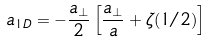<formula> <loc_0><loc_0><loc_500><loc_500>a _ { 1 D } = - \frac { a _ { \perp } } { 2 } \left [ \frac { a _ { \perp } } { a } + \zeta ( 1 / 2 ) \right ]</formula> 